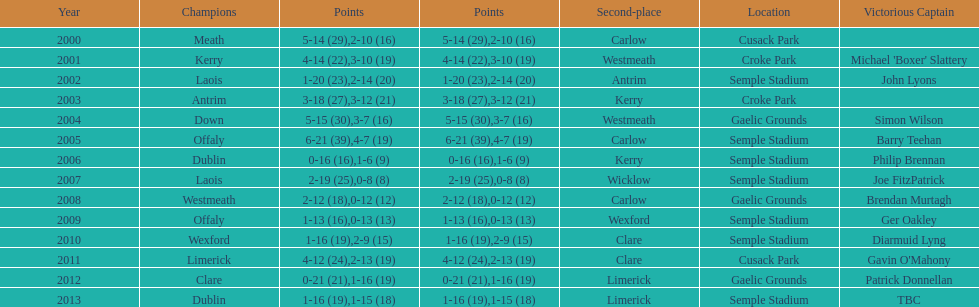Who was the first winning captain? Michael 'Boxer' Slattery. 